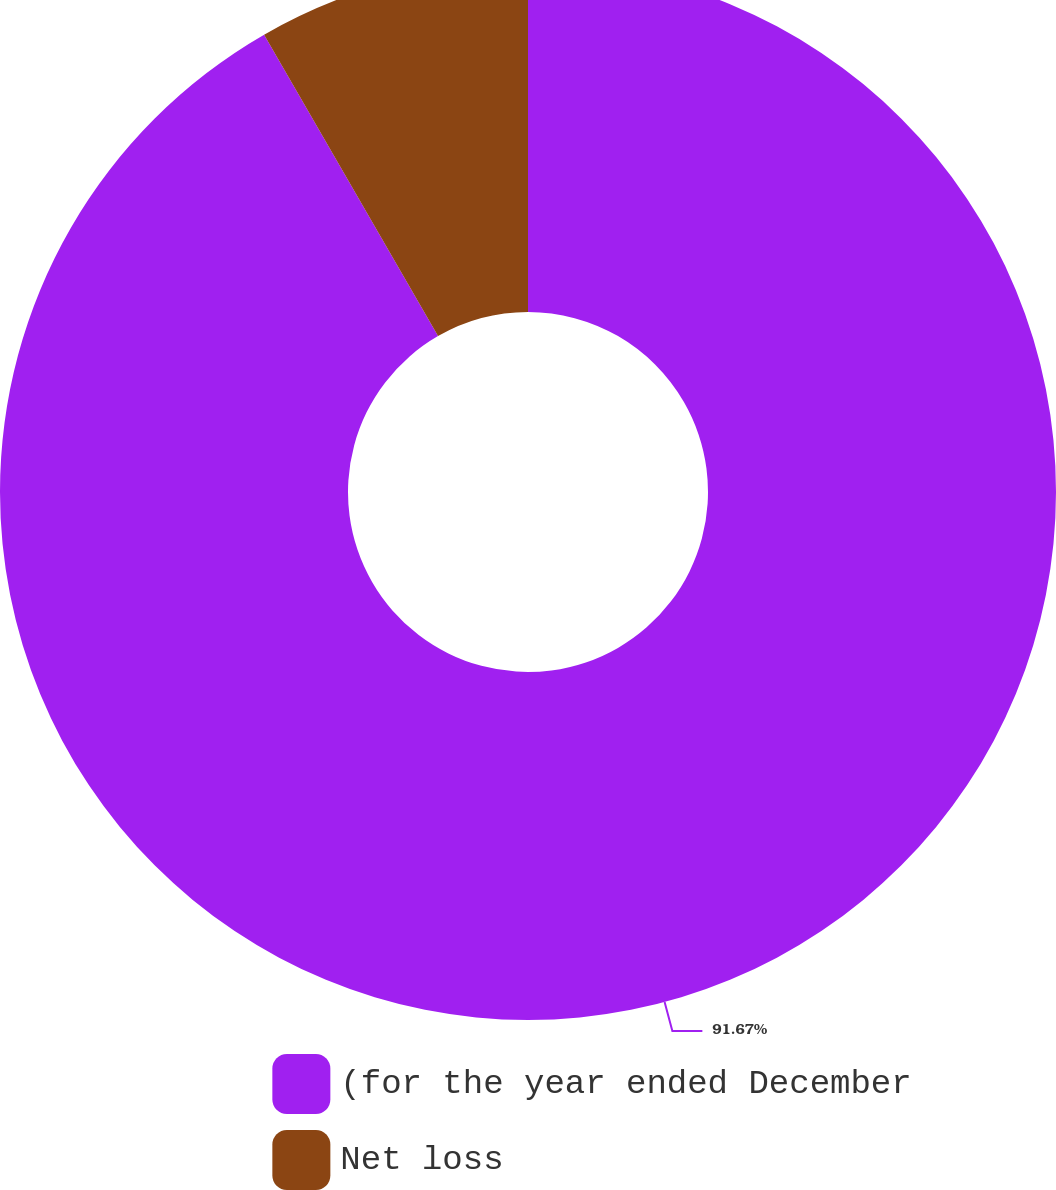Convert chart. <chart><loc_0><loc_0><loc_500><loc_500><pie_chart><fcel>(for the year ended December<fcel>Net loss<nl><fcel>91.67%<fcel>8.33%<nl></chart> 